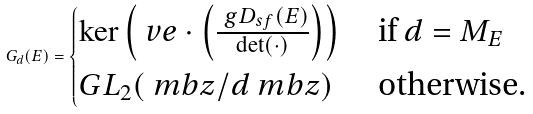Convert formula to latex. <formula><loc_0><loc_0><loc_500><loc_500>G _ { d } ( E ) = \begin{cases} \ker \left ( \ v e \cdot \left ( \frac { \ g D _ { s f } ( E ) } { \det ( \cdot ) } \right ) \right ) & \text { if } d = M _ { E } \\ G L _ { 2 } ( \ m b z / d \ m b z ) & \text { otherwise.} \end{cases}</formula> 